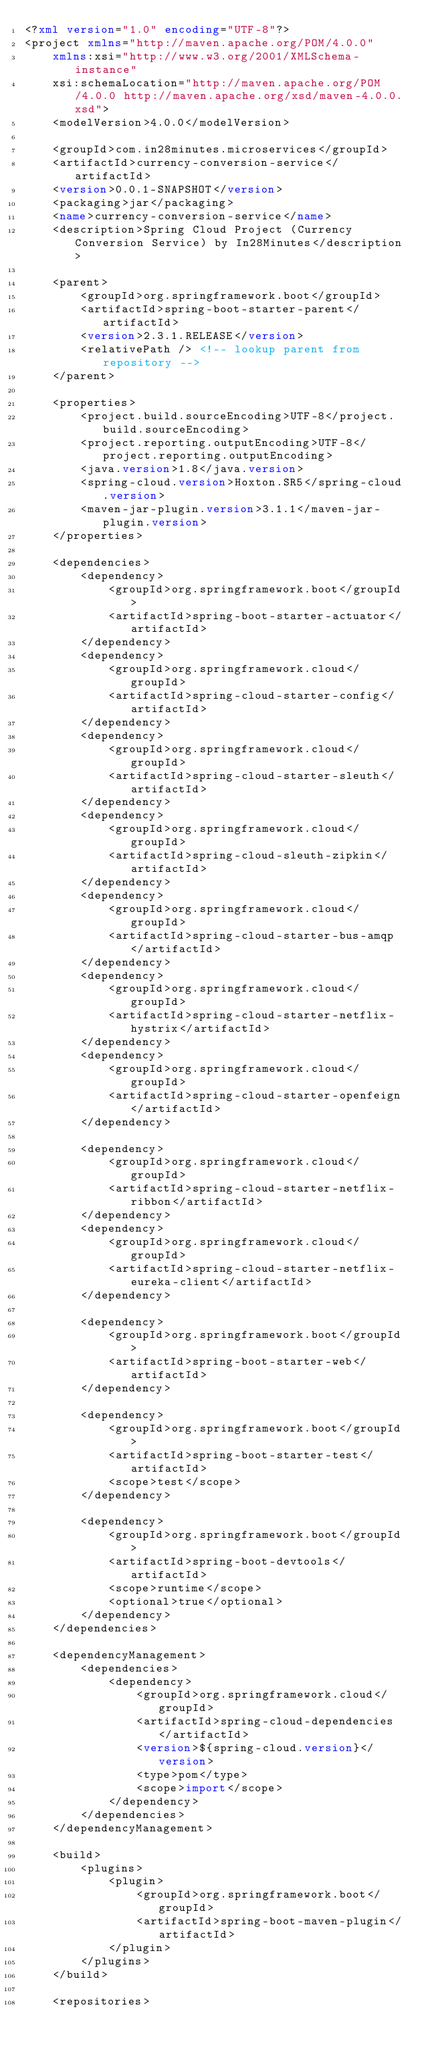<code> <loc_0><loc_0><loc_500><loc_500><_XML_><?xml version="1.0" encoding="UTF-8"?>
<project xmlns="http://maven.apache.org/POM/4.0.0"
	xmlns:xsi="http://www.w3.org/2001/XMLSchema-instance"
	xsi:schemaLocation="http://maven.apache.org/POM/4.0.0 http://maven.apache.org/xsd/maven-4.0.0.xsd">
	<modelVersion>4.0.0</modelVersion>

	<groupId>com.in28minutes.microservices</groupId>
	<artifactId>currency-conversion-service</artifactId>
	<version>0.0.1-SNAPSHOT</version>
	<packaging>jar</packaging>
	<name>currency-conversion-service</name>
	<description>Spring Cloud Project (Currency Conversion Service) by In28Minutes</description>

	<parent>
		<groupId>org.springframework.boot</groupId>
		<artifactId>spring-boot-starter-parent</artifactId>
		<version>2.3.1.RELEASE</version>
		<relativePath /> <!-- lookup parent from repository -->
	</parent>

	<properties>
		<project.build.sourceEncoding>UTF-8</project.build.sourceEncoding>
		<project.reporting.outputEncoding>UTF-8</project.reporting.outputEncoding>
		<java.version>1.8</java.version>
		<spring-cloud.version>Hoxton.SR5</spring-cloud.version>
		<maven-jar-plugin.version>3.1.1</maven-jar-plugin.version>
	</properties>

	<dependencies>
		<dependency>
			<groupId>org.springframework.boot</groupId>
			<artifactId>spring-boot-starter-actuator</artifactId>
		</dependency>
		<dependency>
			<groupId>org.springframework.cloud</groupId>
			<artifactId>spring-cloud-starter-config</artifactId>
		</dependency>
		<dependency>
			<groupId>org.springframework.cloud</groupId>
			<artifactId>spring-cloud-starter-sleuth</artifactId>
		</dependency>
		<dependency>
			<groupId>org.springframework.cloud</groupId>
			<artifactId>spring-cloud-sleuth-zipkin</artifactId>
		</dependency>
		<dependency>
			<groupId>org.springframework.cloud</groupId>
			<artifactId>spring-cloud-starter-bus-amqp</artifactId>
		</dependency>
		<dependency>
			<groupId>org.springframework.cloud</groupId>
			<artifactId>spring-cloud-starter-netflix-hystrix</artifactId>
		</dependency>
		<dependency>
			<groupId>org.springframework.cloud</groupId>
			<artifactId>spring-cloud-starter-openfeign</artifactId>
		</dependency>

		<dependency>
			<groupId>org.springframework.cloud</groupId>
			<artifactId>spring-cloud-starter-netflix-ribbon</artifactId>
		</dependency>
		<dependency>
			<groupId>org.springframework.cloud</groupId>
			<artifactId>spring-cloud-starter-netflix-eureka-client</artifactId>
		</dependency>

		<dependency>
			<groupId>org.springframework.boot</groupId>
			<artifactId>spring-boot-starter-web</artifactId>
		</dependency>

		<dependency>
			<groupId>org.springframework.boot</groupId>
			<artifactId>spring-boot-starter-test</artifactId>
			<scope>test</scope>
		</dependency>

		<dependency>
			<groupId>org.springframework.boot</groupId>
			<artifactId>spring-boot-devtools</artifactId>
			<scope>runtime</scope>
			<optional>true</optional>
		</dependency>
	</dependencies>

	<dependencyManagement>
		<dependencies>
			<dependency>
				<groupId>org.springframework.cloud</groupId>
				<artifactId>spring-cloud-dependencies</artifactId>
				<version>${spring-cloud.version}</version>
				<type>pom</type>
				<scope>import</scope>
			</dependency>
		</dependencies>
	</dependencyManagement>

	<build>
		<plugins>
			<plugin>
				<groupId>org.springframework.boot</groupId>
				<artifactId>spring-boot-maven-plugin</artifactId>
			</plugin>
		</plugins>
	</build>

	<repositories></code> 